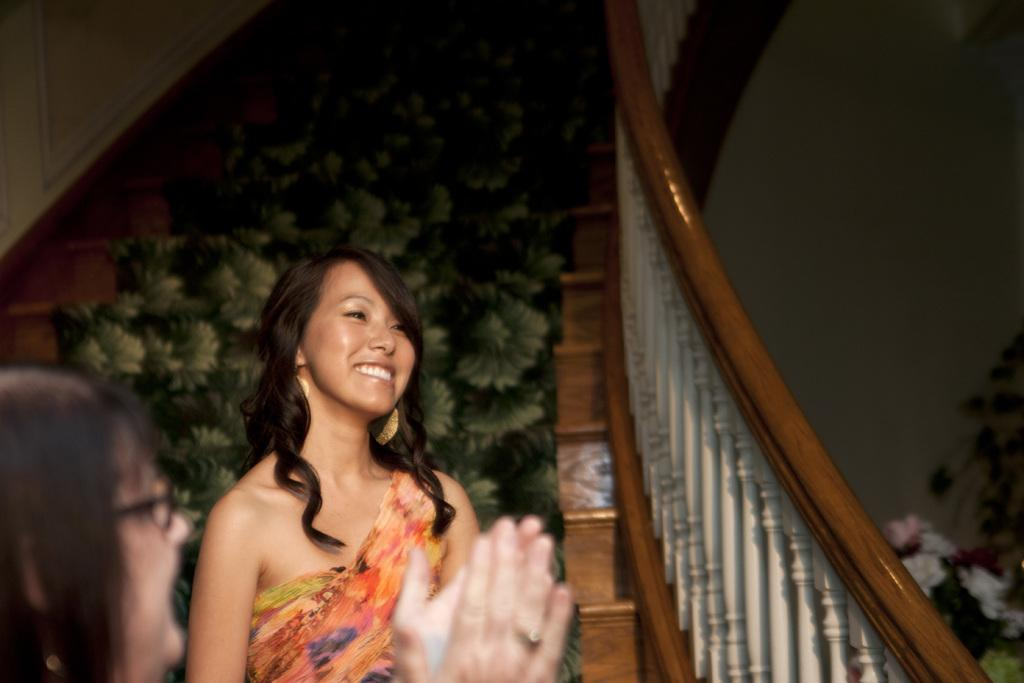How many people are in the image? There are two persons in the image. What is the location of the persons in the image? The persons are in front of a staircase. What can be seen in the middle of the image? There is a carpet in the middle of the image. What type of vegetation is present in the image? There is a plant in the bottom right of the image. What type of slope can be seen in the image? There is no slope present in the image. The image features a staircase, but it is not a slope. 